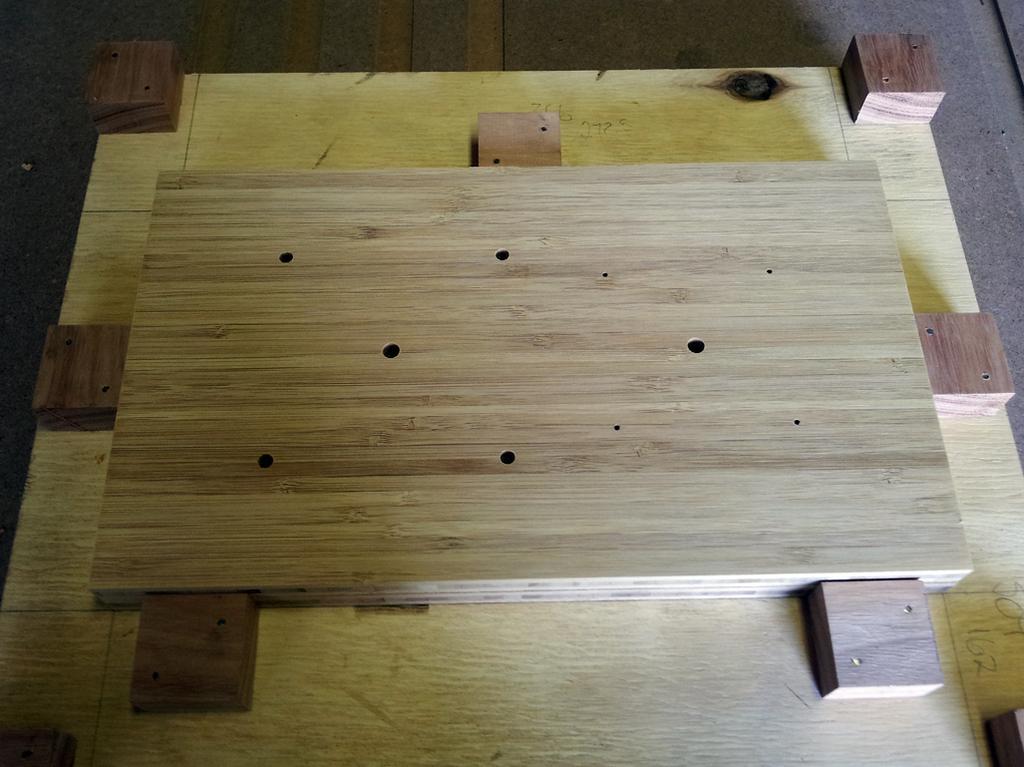In one or two sentences, can you explain what this image depicts? In the middle it is a wooden board. 